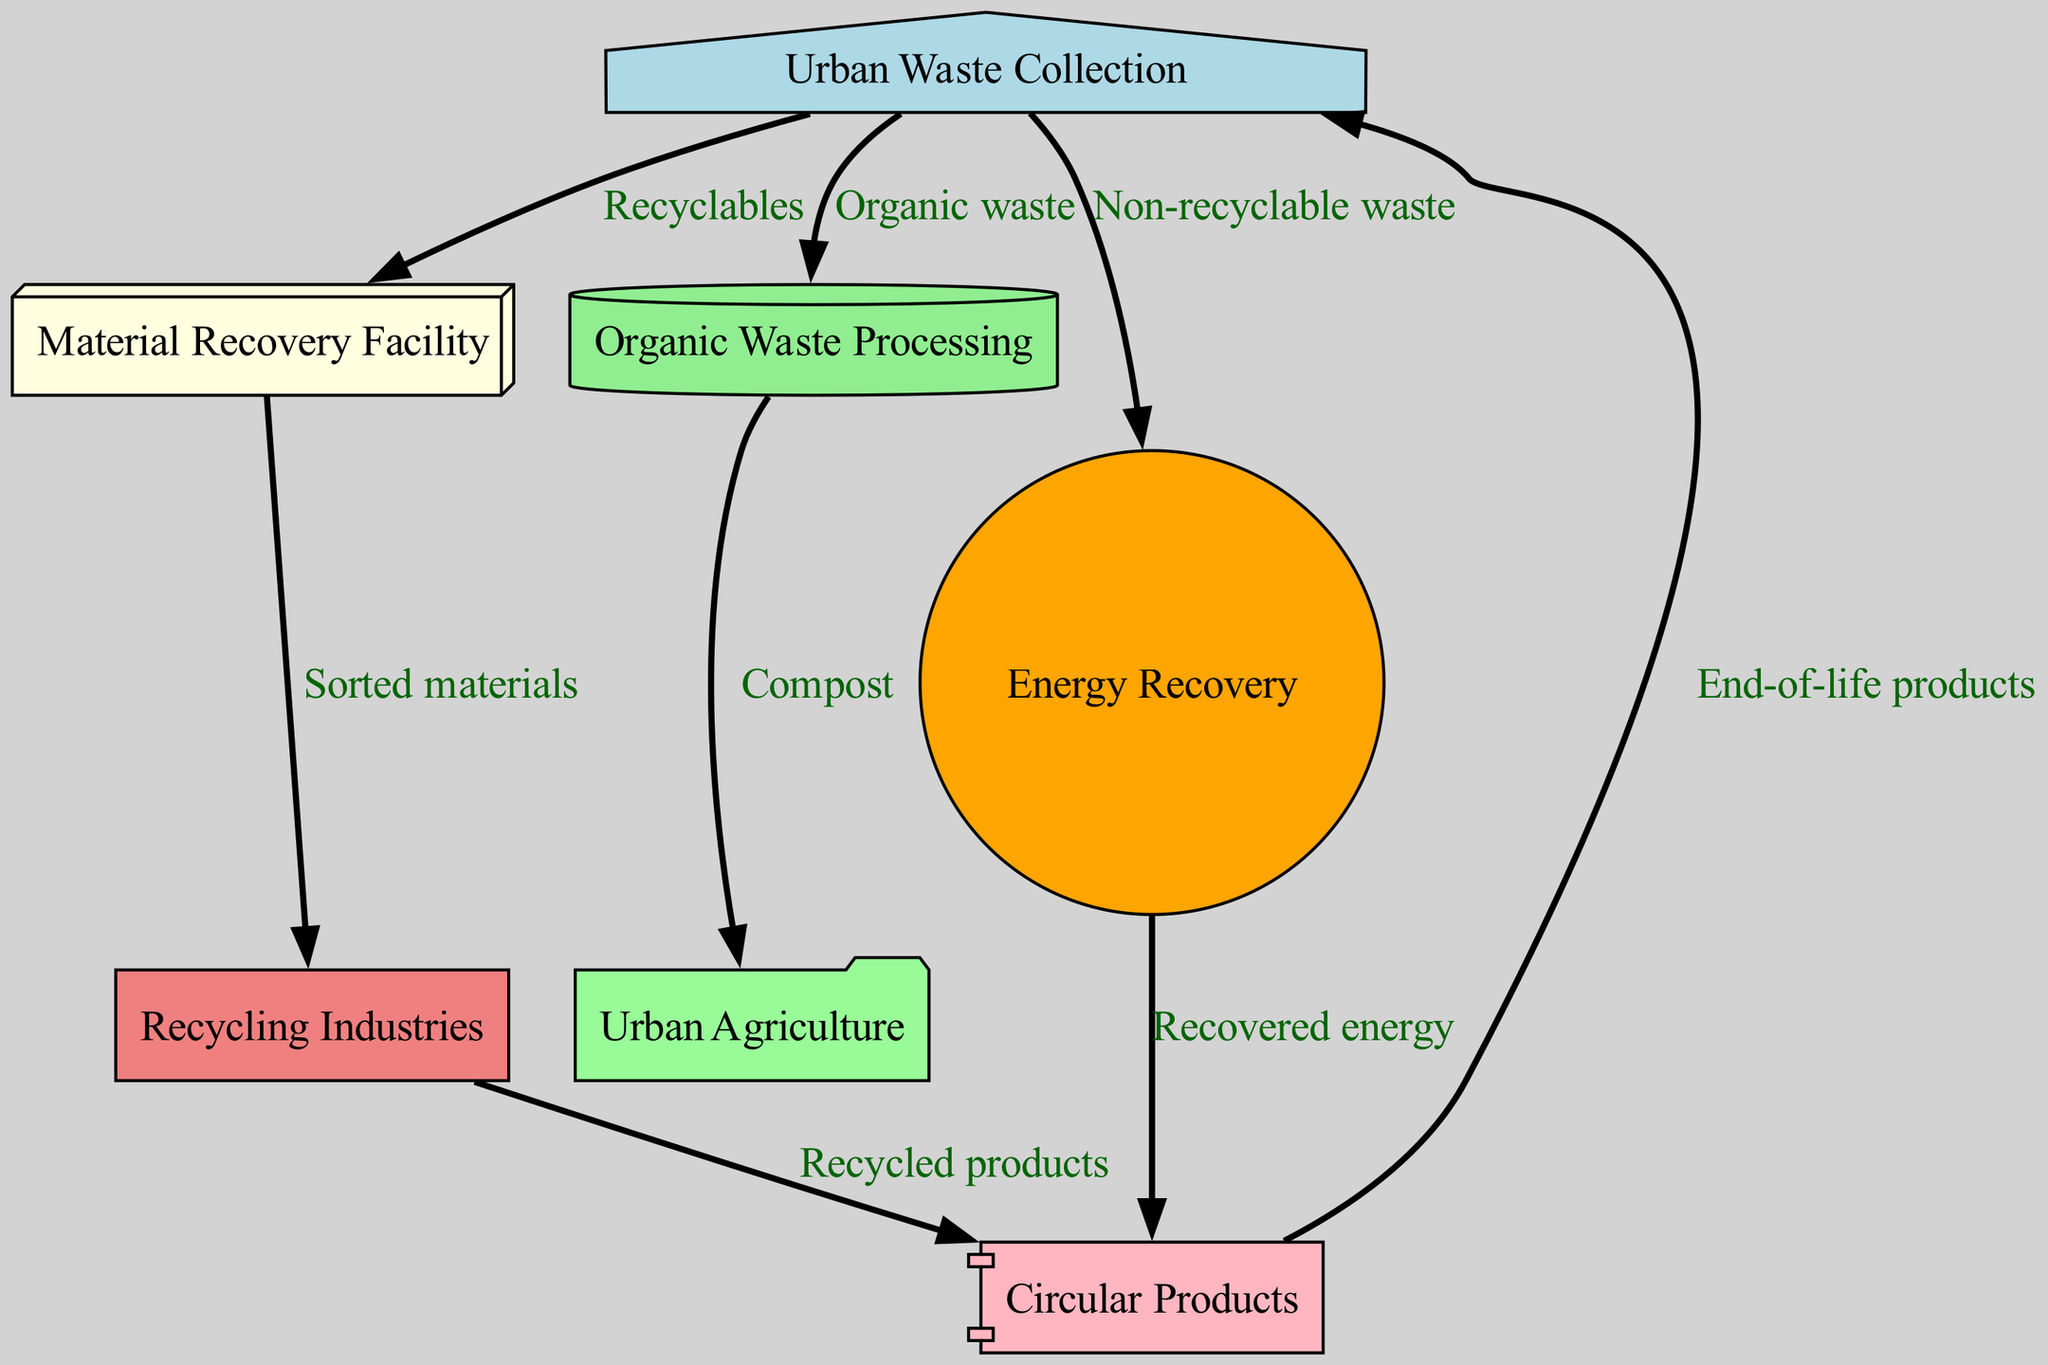What is the number of nodes in the diagram? The diagram lists seven distinct nodes, each representing a different process in the circular economy model. Counting each unique node yields a total of seven.
Answer: 7 What is the relationship between Urban Waste Collection and Material Recovery Facility? Urban Waste Collection is directly connected to the Material Recovery Facility via a labeled edge indicating that it sends Recyclables to the Material Recovery Facility.
Answer: Recyclables What processes are connected to Organic Waste Processing? Organic Waste Processing connects to one node: Urban Agriculture, which receives Compost from Organic Waste Processing, indicating the flow of processed organic waste to urban agriculture practices.
Answer: Urban Agriculture Which node produces Circular Products? The Recycling Industries node is the one that produces Circular Products, as indicated by the edge connecting it to the Circular Products node, labeled with "Recycled products."
Answer: Recycling Industries What type of waste does Energy Recovery deal with? Energy Recovery processes Non-recyclable waste, which is indicated by the arrow from Urban Waste Collection to Energy Recovery, labeled clearly to show that this type of waste flows into the energy recovery process.
Answer: Non-recyclable waste How does the flow of Recyclables begin in the diagram? The flow of Recyclables starts at the Urban Waste Collection node, which collects segregated waste, and then transports the recyclables to the Material Recovery Facility for sorting and processing.
Answer: Urban Waste Collection How many connections does the Circular Products node have? Circular Products has two connections: one from Recycling Industries, indicating the production of recycled products, and another leading back to Urban Waste Collection, which involves the return of end-of-life products. Counting these connections gives a total of two.
Answer: 2 What type of products are created from recovered energy? The edge leading from Energy Recovery to Circular Products establishes that the recovered energy is transformed into Circular Products, indicating that energy recovery contributes to creating eco-designed goods.
Answer: Circular Products What does Organic Waste Processing provide to Urban Agriculture? Organic Waste Processing provides Compost to Urban Agriculture, which is indicated by the clear directional edge connecting the two nodes, showing the flow of composted organic material to urban farming efforts.
Answer: Compost 